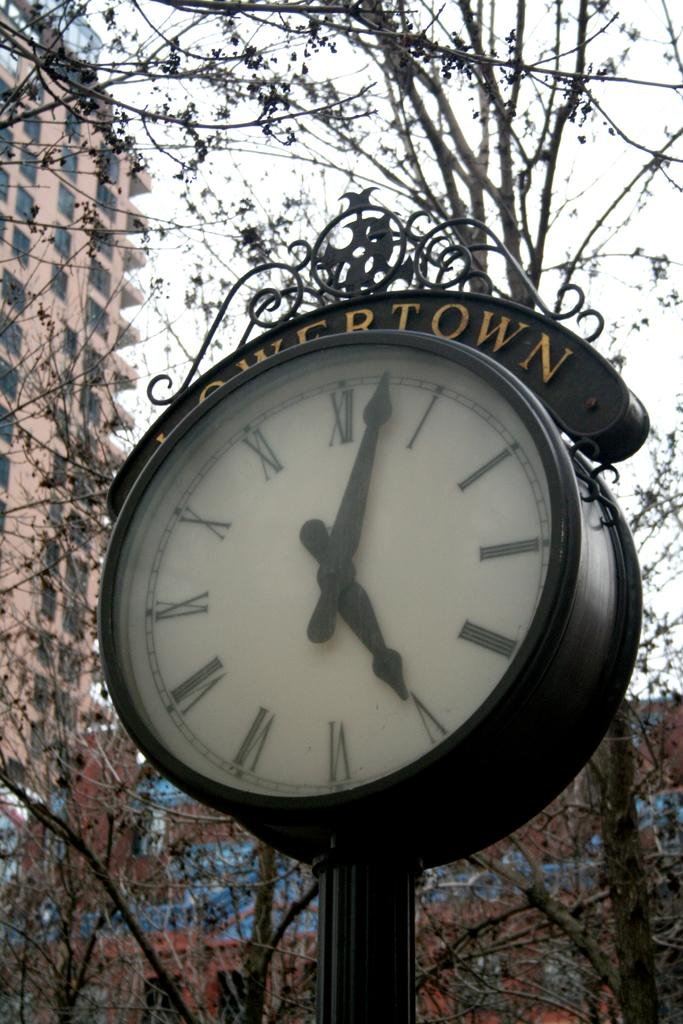<image>
Render a clear and concise summary of the photo. Clock which has the word Lowertown above it. 